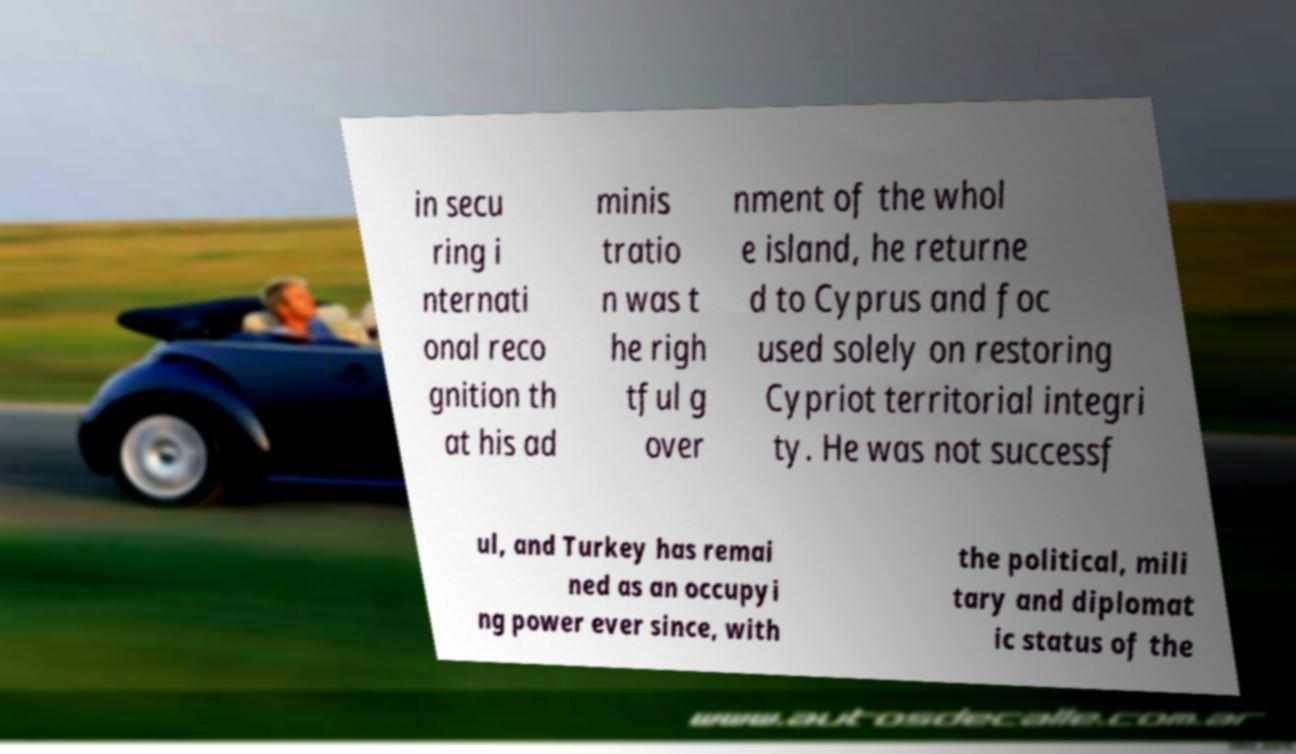For documentation purposes, I need the text within this image transcribed. Could you provide that? in secu ring i nternati onal reco gnition th at his ad minis tratio n was t he righ tful g over nment of the whol e island, he returne d to Cyprus and foc used solely on restoring Cypriot territorial integri ty. He was not successf ul, and Turkey has remai ned as an occupyi ng power ever since, with the political, mili tary and diplomat ic status of the 